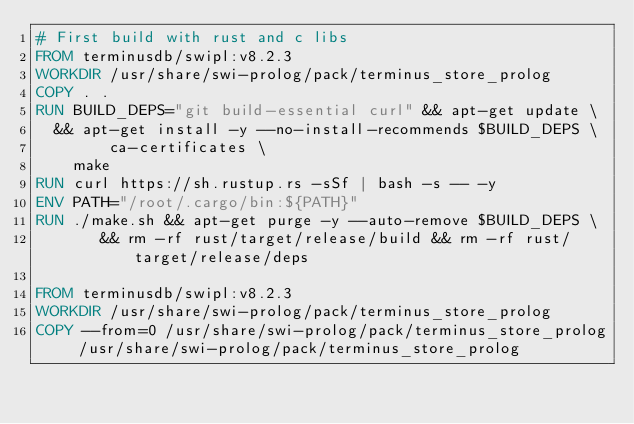<code> <loc_0><loc_0><loc_500><loc_500><_Dockerfile_># First build with rust and c libs
FROM terminusdb/swipl:v8.2.3
WORKDIR /usr/share/swi-prolog/pack/terminus_store_prolog
COPY . .
RUN BUILD_DEPS="git build-essential curl" && apt-get update \
	&& apt-get install -y --no-install-recommends $BUILD_DEPS \
        ca-certificates \
    make
RUN curl https://sh.rustup.rs -sSf | bash -s -- -y
ENV PATH="/root/.cargo/bin:${PATH}"
RUN ./make.sh && apt-get purge -y --auto-remove $BUILD_DEPS \
       && rm -rf rust/target/release/build && rm -rf rust/target/release/deps

FROM terminusdb/swipl:v8.2.3
WORKDIR /usr/share/swi-prolog/pack/terminus_store_prolog
COPY --from=0 /usr/share/swi-prolog/pack/terminus_store_prolog /usr/share/swi-prolog/pack/terminus_store_prolog
</code> 